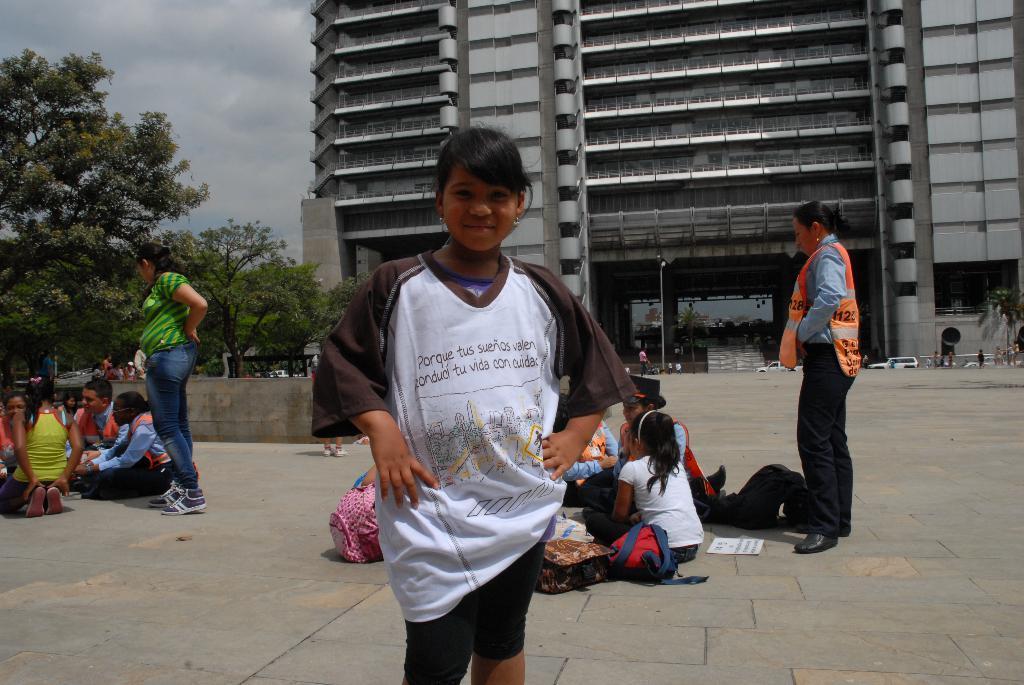Can you describe this image briefly? In this image we can see few people, some of them are sitting and some of them are standing and there are bags, a paper and few objects on the ground and there are few trees, a building, few vehicles and the sky with clouds in the background. 